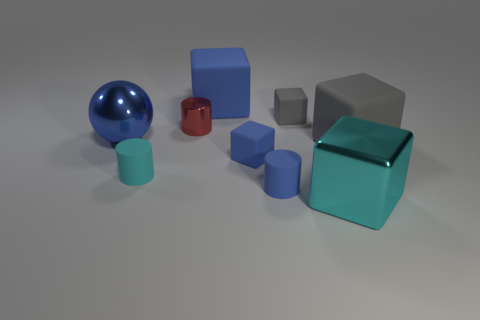What is the color of the large matte thing right of the metallic block?
Keep it short and to the point. Gray. What is the blue thing in front of the blue block that is in front of the shiny sphere made of?
Offer a very short reply. Rubber. Are there any shiny cubes that have the same size as the cyan matte cylinder?
Your answer should be compact. No. What number of things are either gray rubber blocks that are right of the metal cube or matte cylinders that are to the left of the tiny blue matte cylinder?
Your response must be concise. 2. Does the object that is right of the shiny cube have the same size as the gray thing on the left side of the big metallic cube?
Your answer should be very brief. No. Are there any tiny gray objects that are on the left side of the large metallic object behind the large gray thing?
Offer a terse response. No. How many large gray matte cubes are in front of the tiny blue rubber cylinder?
Offer a terse response. 0. How many other things are there of the same color as the large metal ball?
Keep it short and to the point. 3. Is the number of tiny blue matte cylinders that are behind the red metal thing less than the number of cubes on the right side of the cyan cylinder?
Keep it short and to the point. Yes. How many things are small shiny things left of the blue rubber cylinder or tiny blue objects?
Keep it short and to the point. 3. 